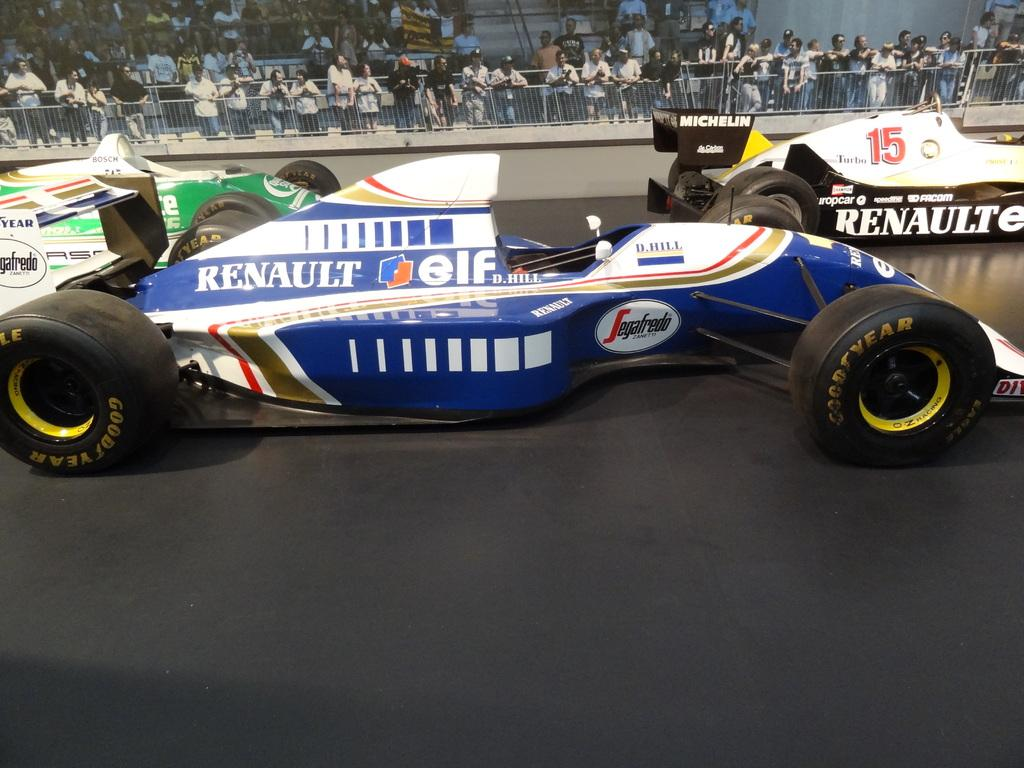What can be seen in the image? There are vehicles in the image. What is visible in the background of the image? There is a fence and a crowd in the background of the image. How many cherries can be seen on the station in the image? There is no station or cherries present in the image. What type of toad is sitting on the fence in the image? There is no toad present in the image; only vehicles, a fence, and a crowd can be seen. 